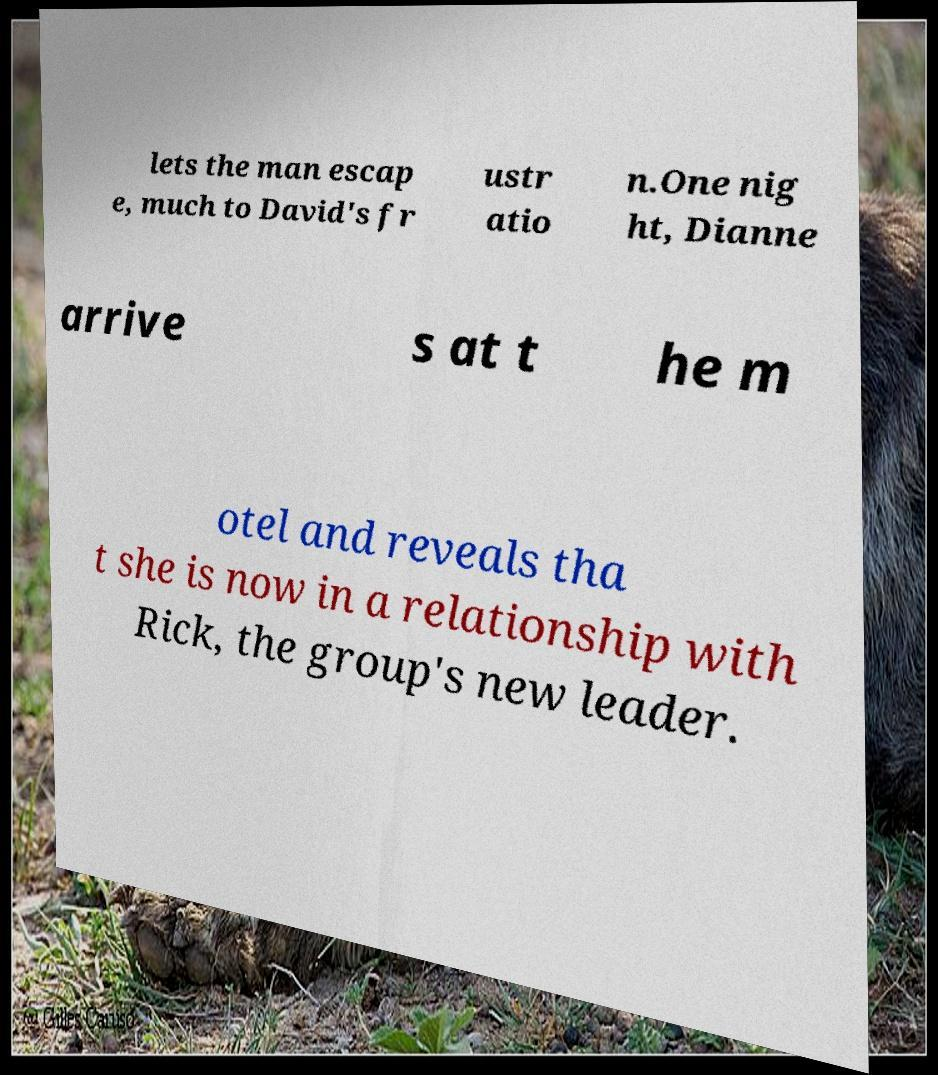For documentation purposes, I need the text within this image transcribed. Could you provide that? lets the man escap e, much to David's fr ustr atio n.One nig ht, Dianne arrive s at t he m otel and reveals tha t she is now in a relationship with Rick, the group's new leader. 